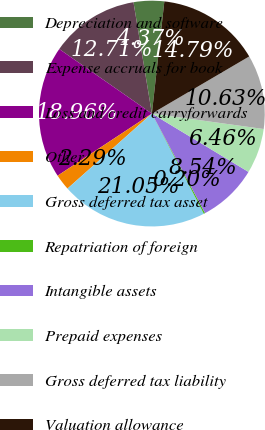Convert chart to OTSL. <chart><loc_0><loc_0><loc_500><loc_500><pie_chart><fcel>Depreciation and software<fcel>Expense accruals for book<fcel>Loss and credit carryforwards<fcel>Other<fcel>Gross deferred tax asset<fcel>Repatriation of foreign<fcel>Intangible assets<fcel>Prepaid expenses<fcel>Gross deferred tax liability<fcel>Valuation allowance<nl><fcel>4.37%<fcel>12.71%<fcel>18.96%<fcel>2.29%<fcel>21.05%<fcel>0.2%<fcel>8.54%<fcel>6.46%<fcel>10.63%<fcel>14.79%<nl></chart> 